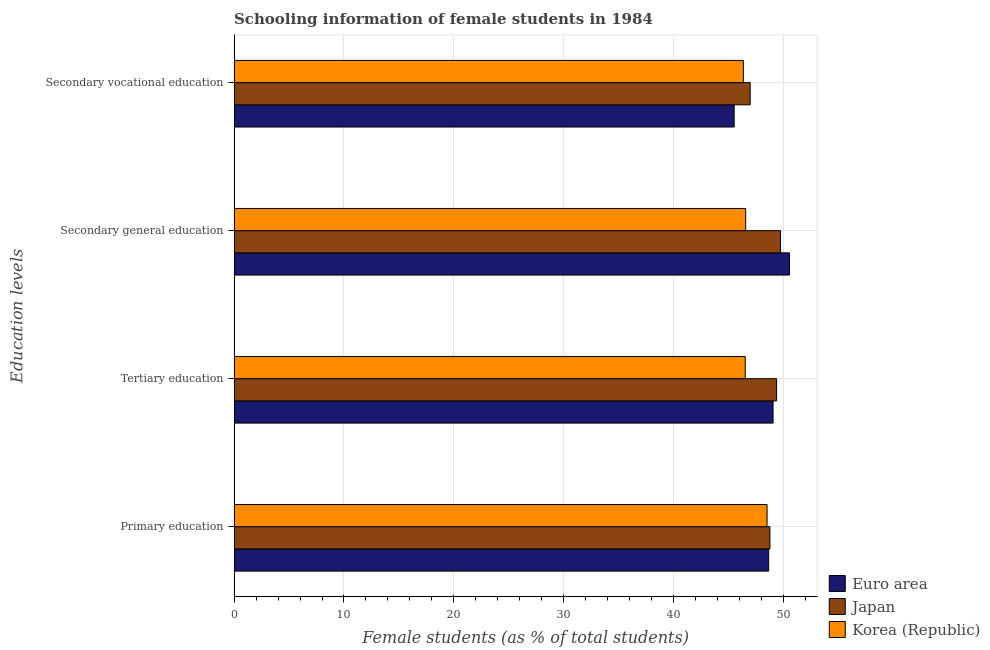How many different coloured bars are there?
Offer a terse response. 3. How many groups of bars are there?
Keep it short and to the point. 4. Are the number of bars per tick equal to the number of legend labels?
Give a very brief answer. Yes. How many bars are there on the 4th tick from the bottom?
Provide a succinct answer. 3. What is the label of the 3rd group of bars from the top?
Provide a succinct answer. Tertiary education. What is the percentage of female students in secondary vocational education in Korea (Republic)?
Provide a short and direct response. 46.36. Across all countries, what is the maximum percentage of female students in tertiary education?
Provide a succinct answer. 49.38. Across all countries, what is the minimum percentage of female students in secondary vocational education?
Your response must be concise. 45.52. What is the total percentage of female students in secondary vocational education in the graph?
Offer a very short reply. 138.85. What is the difference between the percentage of female students in primary education in Japan and that in Euro area?
Offer a very short reply. 0.12. What is the difference between the percentage of female students in primary education in Euro area and the percentage of female students in secondary education in Korea (Republic)?
Make the answer very short. 2.09. What is the average percentage of female students in secondary vocational education per country?
Offer a terse response. 46.28. What is the difference between the percentage of female students in tertiary education and percentage of female students in secondary education in Korea (Republic)?
Your response must be concise. -0.04. In how many countries, is the percentage of female students in secondary vocational education greater than 8 %?
Your response must be concise. 3. What is the ratio of the percentage of female students in primary education in Japan to that in Korea (Republic)?
Provide a short and direct response. 1.01. Is the difference between the percentage of female students in secondary vocational education in Euro area and Korea (Republic) greater than the difference between the percentage of female students in secondary education in Euro area and Korea (Republic)?
Offer a terse response. No. What is the difference between the highest and the second highest percentage of female students in secondary vocational education?
Provide a succinct answer. 0.62. What is the difference between the highest and the lowest percentage of female students in secondary vocational education?
Offer a terse response. 1.46. In how many countries, is the percentage of female students in tertiary education greater than the average percentage of female students in tertiary education taken over all countries?
Offer a terse response. 2. Is the sum of the percentage of female students in secondary vocational education in Euro area and Japan greater than the maximum percentage of female students in primary education across all countries?
Provide a short and direct response. Yes. Is it the case that in every country, the sum of the percentage of female students in primary education and percentage of female students in secondary education is greater than the sum of percentage of female students in secondary vocational education and percentage of female students in tertiary education?
Your answer should be very brief. No. What does the 2nd bar from the top in Tertiary education represents?
Offer a terse response. Japan. Are all the bars in the graph horizontal?
Your answer should be very brief. Yes. How many countries are there in the graph?
Provide a short and direct response. 3. What is the difference between two consecutive major ticks on the X-axis?
Your response must be concise. 10. Are the values on the major ticks of X-axis written in scientific E-notation?
Provide a short and direct response. No. Does the graph contain any zero values?
Your answer should be very brief. No. Does the graph contain grids?
Give a very brief answer. Yes. Where does the legend appear in the graph?
Provide a short and direct response. Bottom right. How many legend labels are there?
Offer a terse response. 3. What is the title of the graph?
Make the answer very short. Schooling information of female students in 1984. Does "Mali" appear as one of the legend labels in the graph?
Give a very brief answer. No. What is the label or title of the X-axis?
Your response must be concise. Female students (as % of total students). What is the label or title of the Y-axis?
Provide a succinct answer. Education levels. What is the Female students (as % of total students) of Euro area in Primary education?
Your answer should be compact. 48.66. What is the Female students (as % of total students) of Japan in Primary education?
Give a very brief answer. 48.77. What is the Female students (as % of total students) of Korea (Republic) in Primary education?
Your response must be concise. 48.51. What is the Female students (as % of total students) of Euro area in Tertiary education?
Ensure brevity in your answer.  49.06. What is the Female students (as % of total students) in Japan in Tertiary education?
Offer a very short reply. 49.38. What is the Female students (as % of total students) in Korea (Republic) in Tertiary education?
Ensure brevity in your answer.  46.53. What is the Female students (as % of total students) of Euro area in Secondary general education?
Give a very brief answer. 50.55. What is the Female students (as % of total students) in Japan in Secondary general education?
Make the answer very short. 49.74. What is the Female students (as % of total students) in Korea (Republic) in Secondary general education?
Your response must be concise. 46.57. What is the Female students (as % of total students) of Euro area in Secondary vocational education?
Your response must be concise. 45.52. What is the Female students (as % of total students) of Japan in Secondary vocational education?
Make the answer very short. 46.98. What is the Female students (as % of total students) of Korea (Republic) in Secondary vocational education?
Make the answer very short. 46.36. Across all Education levels, what is the maximum Female students (as % of total students) of Euro area?
Keep it short and to the point. 50.55. Across all Education levels, what is the maximum Female students (as % of total students) of Japan?
Make the answer very short. 49.74. Across all Education levels, what is the maximum Female students (as % of total students) in Korea (Republic)?
Provide a short and direct response. 48.51. Across all Education levels, what is the minimum Female students (as % of total students) of Euro area?
Offer a terse response. 45.52. Across all Education levels, what is the minimum Female students (as % of total students) in Japan?
Your answer should be very brief. 46.98. Across all Education levels, what is the minimum Female students (as % of total students) in Korea (Republic)?
Your answer should be very brief. 46.36. What is the total Female students (as % of total students) of Euro area in the graph?
Provide a short and direct response. 193.79. What is the total Female students (as % of total students) of Japan in the graph?
Offer a very short reply. 194.88. What is the total Female students (as % of total students) in Korea (Republic) in the graph?
Keep it short and to the point. 187.96. What is the difference between the Female students (as % of total students) of Euro area in Primary education and that in Tertiary education?
Offer a very short reply. -0.4. What is the difference between the Female students (as % of total students) of Japan in Primary education and that in Tertiary education?
Your answer should be very brief. -0.61. What is the difference between the Female students (as % of total students) of Korea (Republic) in Primary education and that in Tertiary education?
Offer a terse response. 1.99. What is the difference between the Female students (as % of total students) in Euro area in Primary education and that in Secondary general education?
Keep it short and to the point. -1.9. What is the difference between the Female students (as % of total students) of Japan in Primary education and that in Secondary general education?
Provide a succinct answer. -0.97. What is the difference between the Female students (as % of total students) in Korea (Republic) in Primary education and that in Secondary general education?
Your answer should be very brief. 1.95. What is the difference between the Female students (as % of total students) in Euro area in Primary education and that in Secondary vocational education?
Make the answer very short. 3.14. What is the difference between the Female students (as % of total students) of Japan in Primary education and that in Secondary vocational education?
Your answer should be compact. 1.8. What is the difference between the Female students (as % of total students) in Korea (Republic) in Primary education and that in Secondary vocational education?
Keep it short and to the point. 2.16. What is the difference between the Female students (as % of total students) in Euro area in Tertiary education and that in Secondary general education?
Your response must be concise. -1.5. What is the difference between the Female students (as % of total students) in Japan in Tertiary education and that in Secondary general education?
Your answer should be very brief. -0.36. What is the difference between the Female students (as % of total students) in Korea (Republic) in Tertiary education and that in Secondary general education?
Ensure brevity in your answer.  -0.04. What is the difference between the Female students (as % of total students) of Euro area in Tertiary education and that in Secondary vocational education?
Provide a short and direct response. 3.54. What is the difference between the Female students (as % of total students) in Japan in Tertiary education and that in Secondary vocational education?
Give a very brief answer. 2.41. What is the difference between the Female students (as % of total students) in Korea (Republic) in Tertiary education and that in Secondary vocational education?
Ensure brevity in your answer.  0.17. What is the difference between the Female students (as % of total students) of Euro area in Secondary general education and that in Secondary vocational education?
Make the answer very short. 5.04. What is the difference between the Female students (as % of total students) of Japan in Secondary general education and that in Secondary vocational education?
Ensure brevity in your answer.  2.76. What is the difference between the Female students (as % of total students) in Korea (Republic) in Secondary general education and that in Secondary vocational education?
Provide a short and direct response. 0.21. What is the difference between the Female students (as % of total students) in Euro area in Primary education and the Female students (as % of total students) in Japan in Tertiary education?
Make the answer very short. -0.72. What is the difference between the Female students (as % of total students) of Euro area in Primary education and the Female students (as % of total students) of Korea (Republic) in Tertiary education?
Provide a succinct answer. 2.13. What is the difference between the Female students (as % of total students) in Japan in Primary education and the Female students (as % of total students) in Korea (Republic) in Tertiary education?
Give a very brief answer. 2.25. What is the difference between the Female students (as % of total students) of Euro area in Primary education and the Female students (as % of total students) of Japan in Secondary general education?
Provide a short and direct response. -1.08. What is the difference between the Female students (as % of total students) of Euro area in Primary education and the Female students (as % of total students) of Korea (Republic) in Secondary general education?
Offer a terse response. 2.09. What is the difference between the Female students (as % of total students) of Japan in Primary education and the Female students (as % of total students) of Korea (Republic) in Secondary general education?
Your response must be concise. 2.21. What is the difference between the Female students (as % of total students) in Euro area in Primary education and the Female students (as % of total students) in Japan in Secondary vocational education?
Make the answer very short. 1.68. What is the difference between the Female students (as % of total students) in Euro area in Primary education and the Female students (as % of total students) in Korea (Republic) in Secondary vocational education?
Give a very brief answer. 2.3. What is the difference between the Female students (as % of total students) in Japan in Primary education and the Female students (as % of total students) in Korea (Republic) in Secondary vocational education?
Ensure brevity in your answer.  2.42. What is the difference between the Female students (as % of total students) in Euro area in Tertiary education and the Female students (as % of total students) in Japan in Secondary general education?
Your response must be concise. -0.68. What is the difference between the Female students (as % of total students) in Euro area in Tertiary education and the Female students (as % of total students) in Korea (Republic) in Secondary general education?
Provide a succinct answer. 2.49. What is the difference between the Female students (as % of total students) in Japan in Tertiary education and the Female students (as % of total students) in Korea (Republic) in Secondary general education?
Ensure brevity in your answer.  2.82. What is the difference between the Female students (as % of total students) in Euro area in Tertiary education and the Female students (as % of total students) in Japan in Secondary vocational education?
Make the answer very short. 2.08. What is the difference between the Female students (as % of total students) of Euro area in Tertiary education and the Female students (as % of total students) of Korea (Republic) in Secondary vocational education?
Offer a terse response. 2.7. What is the difference between the Female students (as % of total students) in Japan in Tertiary education and the Female students (as % of total students) in Korea (Republic) in Secondary vocational education?
Your answer should be compact. 3.03. What is the difference between the Female students (as % of total students) in Euro area in Secondary general education and the Female students (as % of total students) in Japan in Secondary vocational education?
Keep it short and to the point. 3.58. What is the difference between the Female students (as % of total students) of Euro area in Secondary general education and the Female students (as % of total students) of Korea (Republic) in Secondary vocational education?
Ensure brevity in your answer.  4.2. What is the difference between the Female students (as % of total students) in Japan in Secondary general education and the Female students (as % of total students) in Korea (Republic) in Secondary vocational education?
Give a very brief answer. 3.39. What is the average Female students (as % of total students) of Euro area per Education levels?
Give a very brief answer. 48.45. What is the average Female students (as % of total students) of Japan per Education levels?
Give a very brief answer. 48.72. What is the average Female students (as % of total students) in Korea (Republic) per Education levels?
Make the answer very short. 46.99. What is the difference between the Female students (as % of total students) in Euro area and Female students (as % of total students) in Japan in Primary education?
Offer a terse response. -0.12. What is the difference between the Female students (as % of total students) of Euro area and Female students (as % of total students) of Korea (Republic) in Primary education?
Provide a succinct answer. 0.15. What is the difference between the Female students (as % of total students) of Japan and Female students (as % of total students) of Korea (Republic) in Primary education?
Your response must be concise. 0.26. What is the difference between the Female students (as % of total students) in Euro area and Female students (as % of total students) in Japan in Tertiary education?
Offer a terse response. -0.32. What is the difference between the Female students (as % of total students) of Euro area and Female students (as % of total students) of Korea (Republic) in Tertiary education?
Offer a very short reply. 2.53. What is the difference between the Female students (as % of total students) in Japan and Female students (as % of total students) in Korea (Republic) in Tertiary education?
Your answer should be compact. 2.86. What is the difference between the Female students (as % of total students) of Euro area and Female students (as % of total students) of Japan in Secondary general education?
Your answer should be compact. 0.81. What is the difference between the Female students (as % of total students) in Euro area and Female students (as % of total students) in Korea (Republic) in Secondary general education?
Your answer should be compact. 3.99. What is the difference between the Female students (as % of total students) of Japan and Female students (as % of total students) of Korea (Republic) in Secondary general education?
Make the answer very short. 3.18. What is the difference between the Female students (as % of total students) in Euro area and Female students (as % of total students) in Japan in Secondary vocational education?
Provide a short and direct response. -1.46. What is the difference between the Female students (as % of total students) of Euro area and Female students (as % of total students) of Korea (Republic) in Secondary vocational education?
Your answer should be compact. -0.84. What is the difference between the Female students (as % of total students) of Japan and Female students (as % of total students) of Korea (Republic) in Secondary vocational education?
Your answer should be very brief. 0.62. What is the ratio of the Female students (as % of total students) of Japan in Primary education to that in Tertiary education?
Your response must be concise. 0.99. What is the ratio of the Female students (as % of total students) of Korea (Republic) in Primary education to that in Tertiary education?
Keep it short and to the point. 1.04. What is the ratio of the Female students (as % of total students) of Euro area in Primary education to that in Secondary general education?
Offer a terse response. 0.96. What is the ratio of the Female students (as % of total students) in Japan in Primary education to that in Secondary general education?
Your response must be concise. 0.98. What is the ratio of the Female students (as % of total students) in Korea (Republic) in Primary education to that in Secondary general education?
Your response must be concise. 1.04. What is the ratio of the Female students (as % of total students) of Euro area in Primary education to that in Secondary vocational education?
Make the answer very short. 1.07. What is the ratio of the Female students (as % of total students) in Japan in Primary education to that in Secondary vocational education?
Provide a succinct answer. 1.04. What is the ratio of the Female students (as % of total students) in Korea (Republic) in Primary education to that in Secondary vocational education?
Provide a succinct answer. 1.05. What is the ratio of the Female students (as % of total students) in Euro area in Tertiary education to that in Secondary general education?
Your answer should be compact. 0.97. What is the ratio of the Female students (as % of total students) in Japan in Tertiary education to that in Secondary general education?
Your answer should be very brief. 0.99. What is the ratio of the Female students (as % of total students) of Korea (Republic) in Tertiary education to that in Secondary general education?
Your answer should be compact. 1. What is the ratio of the Female students (as % of total students) in Euro area in Tertiary education to that in Secondary vocational education?
Give a very brief answer. 1.08. What is the ratio of the Female students (as % of total students) of Japan in Tertiary education to that in Secondary vocational education?
Offer a very short reply. 1.05. What is the ratio of the Female students (as % of total students) in Korea (Republic) in Tertiary education to that in Secondary vocational education?
Offer a very short reply. 1. What is the ratio of the Female students (as % of total students) of Euro area in Secondary general education to that in Secondary vocational education?
Make the answer very short. 1.11. What is the ratio of the Female students (as % of total students) of Japan in Secondary general education to that in Secondary vocational education?
Your answer should be very brief. 1.06. What is the ratio of the Female students (as % of total students) of Korea (Republic) in Secondary general education to that in Secondary vocational education?
Offer a terse response. 1. What is the difference between the highest and the second highest Female students (as % of total students) of Euro area?
Make the answer very short. 1.5. What is the difference between the highest and the second highest Female students (as % of total students) in Japan?
Your answer should be compact. 0.36. What is the difference between the highest and the second highest Female students (as % of total students) of Korea (Republic)?
Offer a terse response. 1.95. What is the difference between the highest and the lowest Female students (as % of total students) of Euro area?
Ensure brevity in your answer.  5.04. What is the difference between the highest and the lowest Female students (as % of total students) of Japan?
Your answer should be very brief. 2.76. What is the difference between the highest and the lowest Female students (as % of total students) in Korea (Republic)?
Provide a short and direct response. 2.16. 